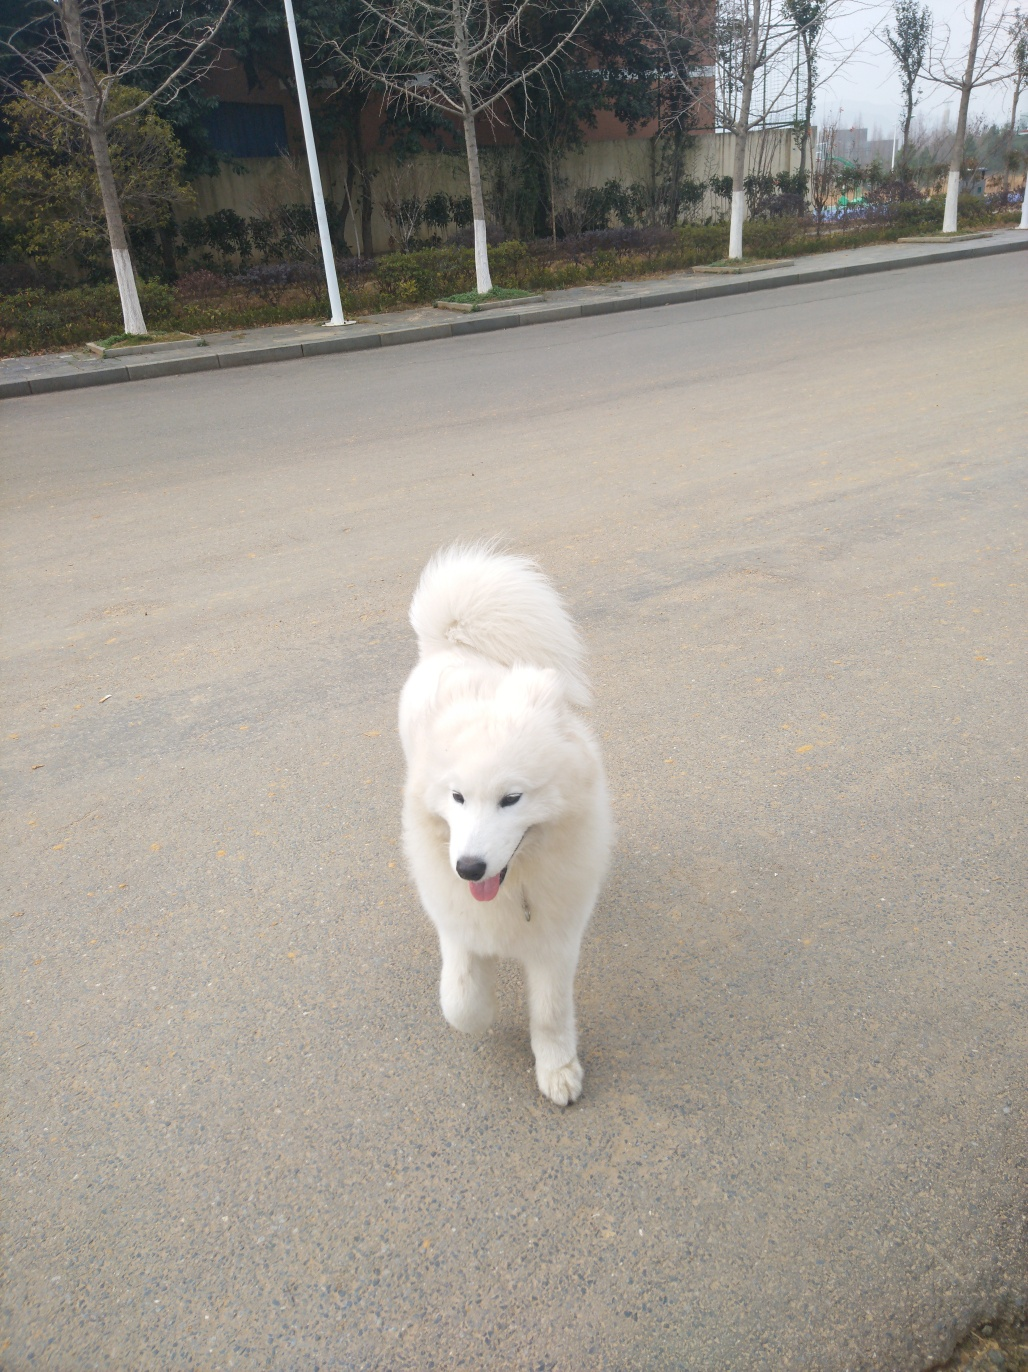What breed is the dog, and what are some typical characteristics of that breed? The dog resembles a Samoyed, a breed known for its fluffy white coat, friendly disposition, and smiling expression. Samoyeds are typically playful, gentle, and good-natured, making them excellent family pets. Their thick coat requires regular grooming to maintain its lustrous appearance. 